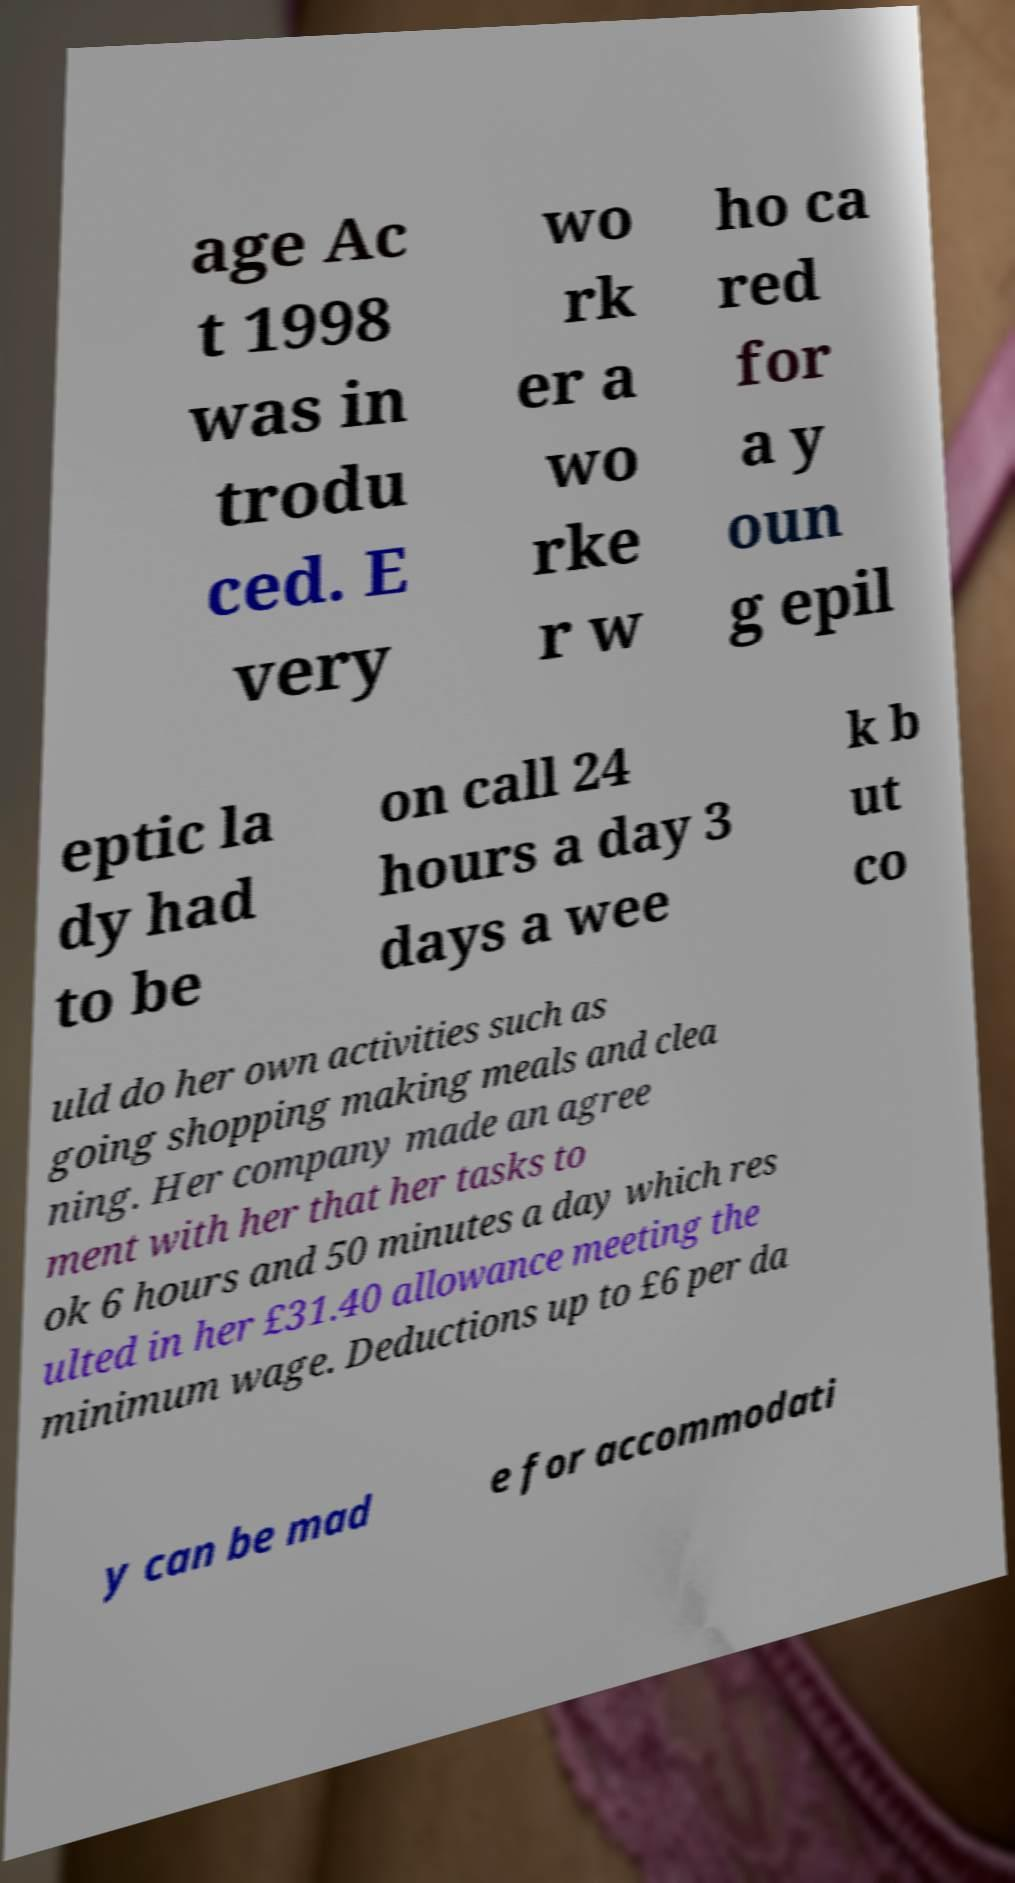Please identify and transcribe the text found in this image. age Ac t 1998 was in trodu ced. E very wo rk er a wo rke r w ho ca red for a y oun g epil eptic la dy had to be on call 24 hours a day 3 days a wee k b ut co uld do her own activities such as going shopping making meals and clea ning. Her company made an agree ment with her that her tasks to ok 6 hours and 50 minutes a day which res ulted in her £31.40 allowance meeting the minimum wage. Deductions up to £6 per da y can be mad e for accommodati 